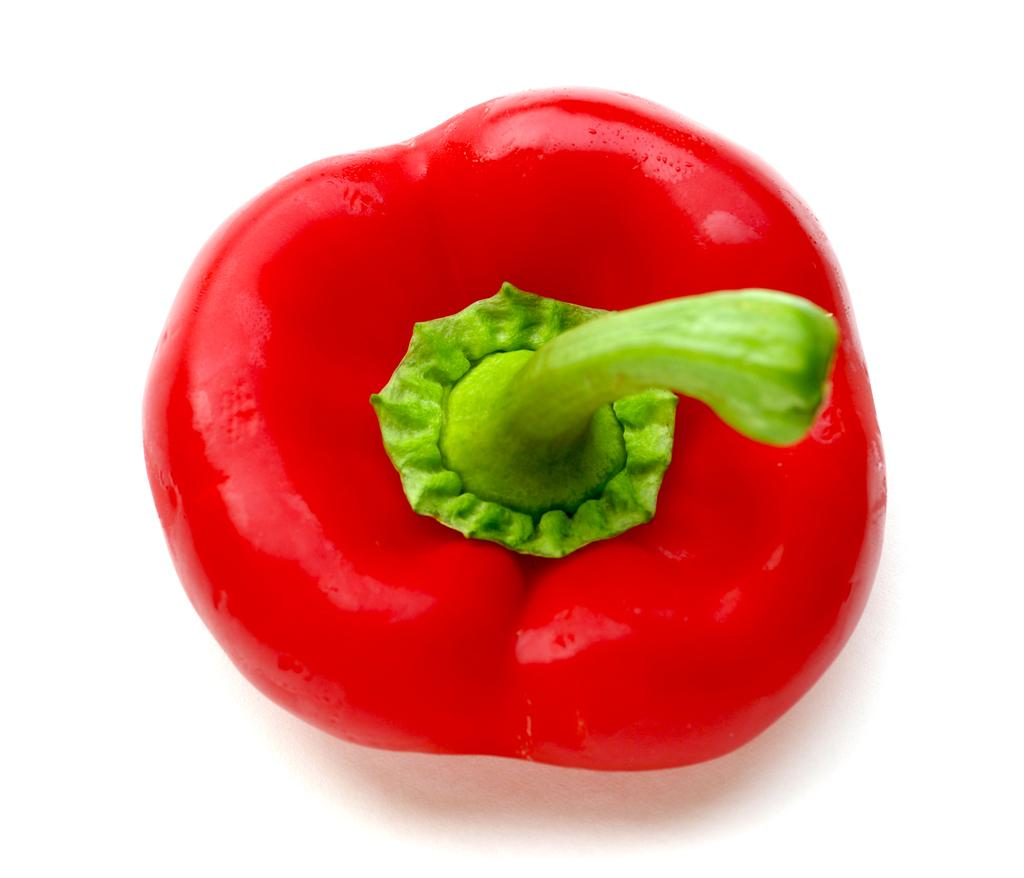What type of vegetable is present in the image? There is a red capsicum in the image. What color is the stem of the capsicum? The capsicum has a green stem. What color is the surface on which the capsicum is placed? The surface in the image is white. What type of yam is growing in the territory shown in the image? There is no yam or territory present in the image; it features a red capsicum with a green stem on a white surface. Can you tell me how many swings are visible in the image? There are no swings present in the image. 